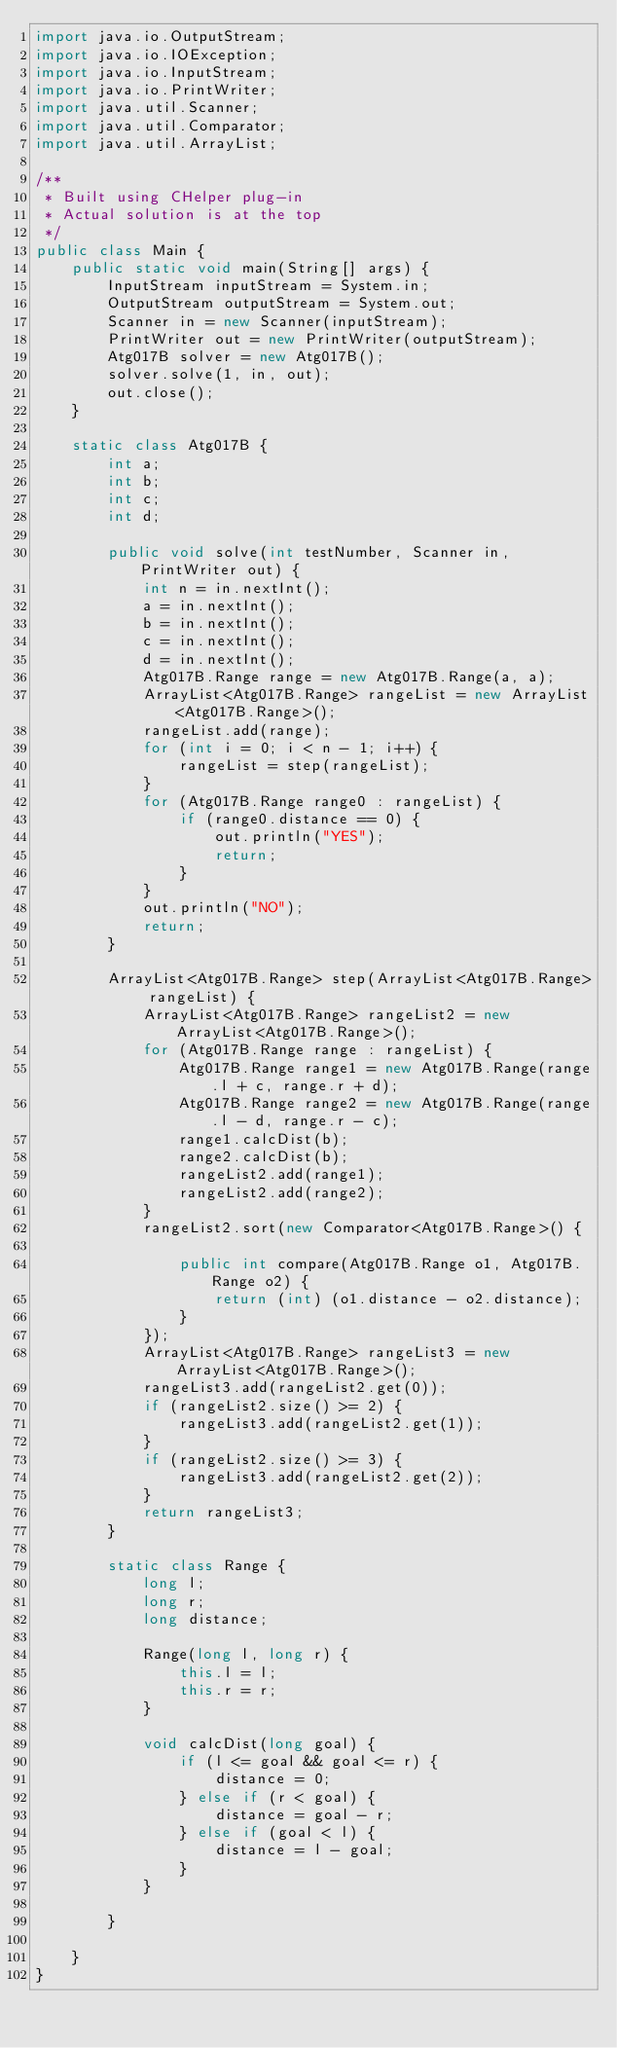<code> <loc_0><loc_0><loc_500><loc_500><_Java_>import java.io.OutputStream;
import java.io.IOException;
import java.io.InputStream;
import java.io.PrintWriter;
import java.util.Scanner;
import java.util.Comparator;
import java.util.ArrayList;

/**
 * Built using CHelper plug-in
 * Actual solution is at the top
 */
public class Main {
    public static void main(String[] args) {
        InputStream inputStream = System.in;
        OutputStream outputStream = System.out;
        Scanner in = new Scanner(inputStream);
        PrintWriter out = new PrintWriter(outputStream);
        Atg017B solver = new Atg017B();
        solver.solve(1, in, out);
        out.close();
    }

    static class Atg017B {
        int a;
        int b;
        int c;
        int d;

        public void solve(int testNumber, Scanner in, PrintWriter out) {
            int n = in.nextInt();
            a = in.nextInt();
            b = in.nextInt();
            c = in.nextInt();
            d = in.nextInt();
            Atg017B.Range range = new Atg017B.Range(a, a);
            ArrayList<Atg017B.Range> rangeList = new ArrayList<Atg017B.Range>();
            rangeList.add(range);
            for (int i = 0; i < n - 1; i++) {
                rangeList = step(rangeList);
            }
            for (Atg017B.Range range0 : rangeList) {
                if (range0.distance == 0) {
                    out.println("YES");
                    return;
                }
            }
            out.println("NO");
            return;
        }

        ArrayList<Atg017B.Range> step(ArrayList<Atg017B.Range> rangeList) {
            ArrayList<Atg017B.Range> rangeList2 = new ArrayList<Atg017B.Range>();
            for (Atg017B.Range range : rangeList) {
                Atg017B.Range range1 = new Atg017B.Range(range.l + c, range.r + d);
                Atg017B.Range range2 = new Atg017B.Range(range.l - d, range.r - c);
                range1.calcDist(b);
                range2.calcDist(b);
                rangeList2.add(range1);
                rangeList2.add(range2);
            }
            rangeList2.sort(new Comparator<Atg017B.Range>() {

                public int compare(Atg017B.Range o1, Atg017B.Range o2) {
                    return (int) (o1.distance - o2.distance);
                }
            });
            ArrayList<Atg017B.Range> rangeList3 = new ArrayList<Atg017B.Range>();
            rangeList3.add(rangeList2.get(0));
            if (rangeList2.size() >= 2) {
                rangeList3.add(rangeList2.get(1));
            }
            if (rangeList2.size() >= 3) {
                rangeList3.add(rangeList2.get(2));
            }
            return rangeList3;
        }

        static class Range {
            long l;
            long r;
            long distance;

            Range(long l, long r) {
                this.l = l;
                this.r = r;
            }

            void calcDist(long goal) {
                if (l <= goal && goal <= r) {
                    distance = 0;
                } else if (r < goal) {
                    distance = goal - r;
                } else if (goal < l) {
                    distance = l - goal;
                }
            }

        }

    }
}

</code> 